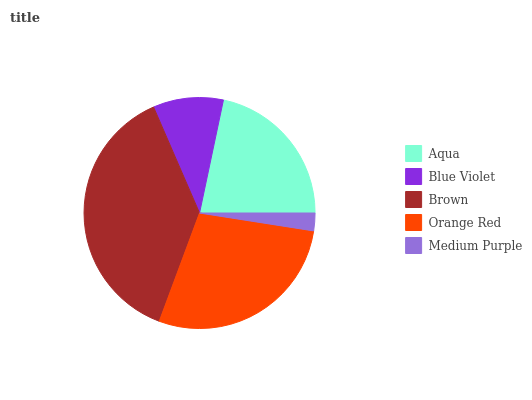Is Medium Purple the minimum?
Answer yes or no. Yes. Is Brown the maximum?
Answer yes or no. Yes. Is Blue Violet the minimum?
Answer yes or no. No. Is Blue Violet the maximum?
Answer yes or no. No. Is Aqua greater than Blue Violet?
Answer yes or no. Yes. Is Blue Violet less than Aqua?
Answer yes or no. Yes. Is Blue Violet greater than Aqua?
Answer yes or no. No. Is Aqua less than Blue Violet?
Answer yes or no. No. Is Aqua the high median?
Answer yes or no. Yes. Is Aqua the low median?
Answer yes or no. Yes. Is Brown the high median?
Answer yes or no. No. Is Orange Red the low median?
Answer yes or no. No. 